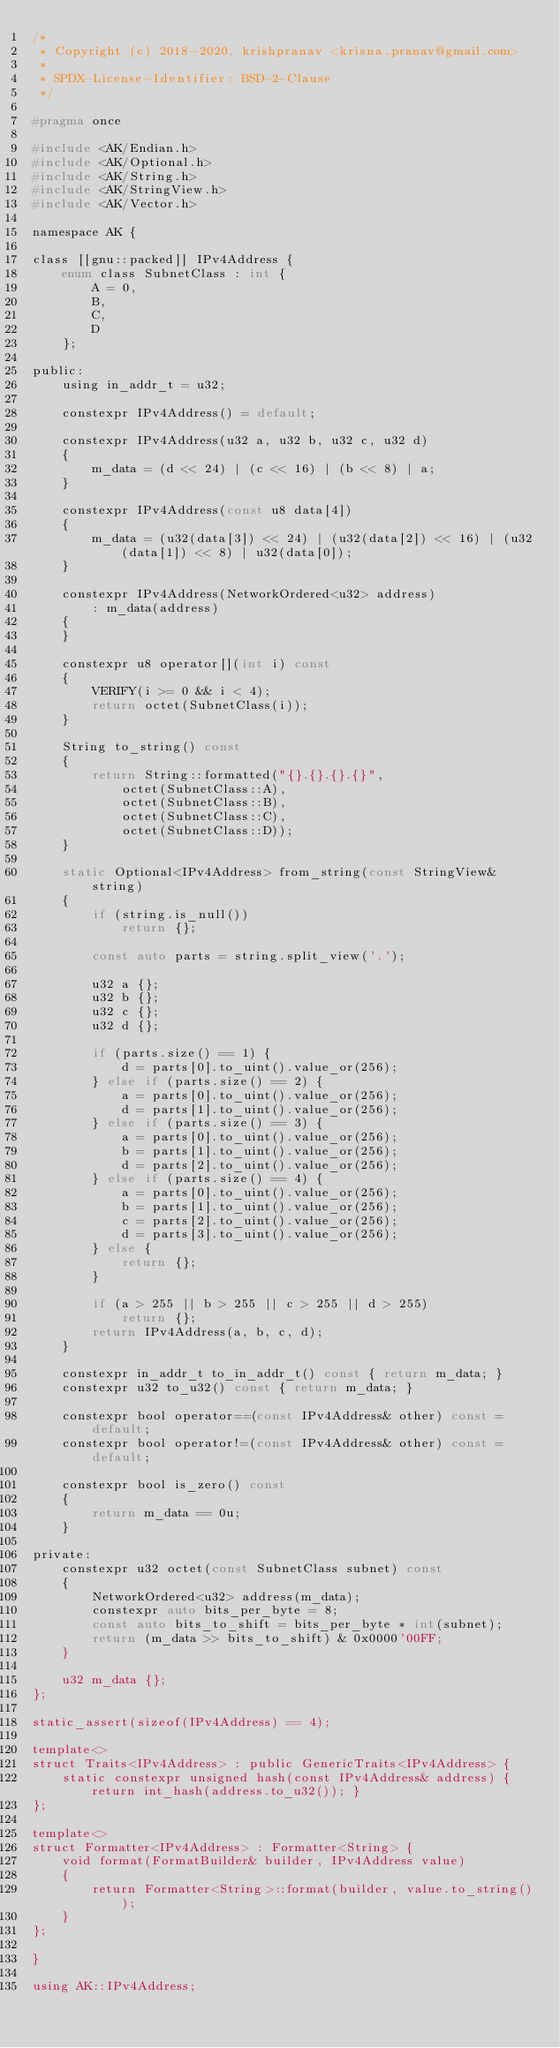<code> <loc_0><loc_0><loc_500><loc_500><_C_>/*
 * Copyright (c) 2018-2020, krishpranav <krisna.pranav@gmail.com>
 *
 * SPDX-License-Identifier: BSD-2-Clause
 */

#pragma once

#include <AK/Endian.h>
#include <AK/Optional.h>
#include <AK/String.h>
#include <AK/StringView.h>
#include <AK/Vector.h>

namespace AK {

class [[gnu::packed]] IPv4Address {
    enum class SubnetClass : int {
        A = 0,
        B,
        C,
        D
    };

public:
    using in_addr_t = u32;

    constexpr IPv4Address() = default;

    constexpr IPv4Address(u32 a, u32 b, u32 c, u32 d)
    {
        m_data = (d << 24) | (c << 16) | (b << 8) | a;
    }

    constexpr IPv4Address(const u8 data[4])
    {
        m_data = (u32(data[3]) << 24) | (u32(data[2]) << 16) | (u32(data[1]) << 8) | u32(data[0]);
    }

    constexpr IPv4Address(NetworkOrdered<u32> address)
        : m_data(address)
    {
    }

    constexpr u8 operator[](int i) const
    {
        VERIFY(i >= 0 && i < 4);
        return octet(SubnetClass(i));
    }

    String to_string() const
    {
        return String::formatted("{}.{}.{}.{}",
            octet(SubnetClass::A),
            octet(SubnetClass::B),
            octet(SubnetClass::C),
            octet(SubnetClass::D));
    }

    static Optional<IPv4Address> from_string(const StringView& string)
    {
        if (string.is_null())
            return {};

        const auto parts = string.split_view('.');

        u32 a {};
        u32 b {};
        u32 c {};
        u32 d {};

        if (parts.size() == 1) {
            d = parts[0].to_uint().value_or(256);
        } else if (parts.size() == 2) {
            a = parts[0].to_uint().value_or(256);
            d = parts[1].to_uint().value_or(256);
        } else if (parts.size() == 3) {
            a = parts[0].to_uint().value_or(256);
            b = parts[1].to_uint().value_or(256);
            d = parts[2].to_uint().value_or(256);
        } else if (parts.size() == 4) {
            a = parts[0].to_uint().value_or(256);
            b = parts[1].to_uint().value_or(256);
            c = parts[2].to_uint().value_or(256);
            d = parts[3].to_uint().value_or(256);
        } else {
            return {};
        }

        if (a > 255 || b > 255 || c > 255 || d > 255)
            return {};
        return IPv4Address(a, b, c, d);
    }

    constexpr in_addr_t to_in_addr_t() const { return m_data; }
    constexpr u32 to_u32() const { return m_data; }

    constexpr bool operator==(const IPv4Address& other) const = default;
    constexpr bool operator!=(const IPv4Address& other) const = default;

    constexpr bool is_zero() const
    {
        return m_data == 0u;
    }

private:
    constexpr u32 octet(const SubnetClass subnet) const
    {
        NetworkOrdered<u32> address(m_data);
        constexpr auto bits_per_byte = 8;
        const auto bits_to_shift = bits_per_byte * int(subnet);
        return (m_data >> bits_to_shift) & 0x0000'00FF;
    }

    u32 m_data {};
};

static_assert(sizeof(IPv4Address) == 4);

template<>
struct Traits<IPv4Address> : public GenericTraits<IPv4Address> {
    static constexpr unsigned hash(const IPv4Address& address) { return int_hash(address.to_u32()); }
};

template<>
struct Formatter<IPv4Address> : Formatter<String> {
    void format(FormatBuilder& builder, IPv4Address value)
    {
        return Formatter<String>::format(builder, value.to_string());
    }
};

}

using AK::IPv4Address;
</code> 